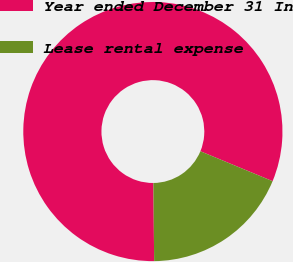<chart> <loc_0><loc_0><loc_500><loc_500><pie_chart><fcel>Year ended December 31 In<fcel>Lease rental expense<nl><fcel>81.41%<fcel>18.59%<nl></chart> 